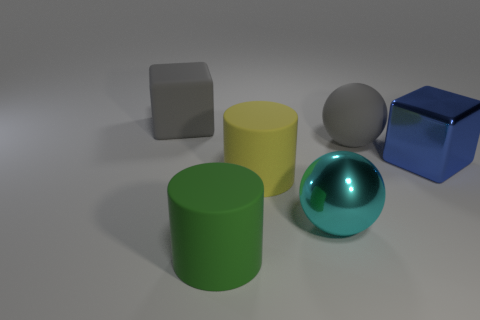What shape is the big matte object behind the large gray thing that is in front of the big gray thing on the left side of the yellow thing?
Your response must be concise. Cube. What number of other objects are there of the same shape as the blue metallic object?
Keep it short and to the point. 1. What number of metal objects are either large blue cubes or green objects?
Give a very brief answer. 1. There is a yellow thing to the left of the big block right of the large green matte cylinder; what is its material?
Your answer should be very brief. Rubber. Are there more green rubber cylinders in front of the rubber block than tiny green balls?
Ensure brevity in your answer.  Yes. Are there any large balls made of the same material as the large yellow object?
Provide a short and direct response. Yes. There is a gray matte object that is on the right side of the gray rubber cube; is its shape the same as the green matte object?
Give a very brief answer. No. There is a cube that is right of the big cube left of the gray rubber sphere; what number of big blue objects are behind it?
Your answer should be compact. 0. Is the number of shiny things behind the large blue thing less than the number of rubber things in front of the big shiny ball?
Ensure brevity in your answer.  Yes. The other thing that is the same shape as the large green matte thing is what color?
Ensure brevity in your answer.  Yellow. 